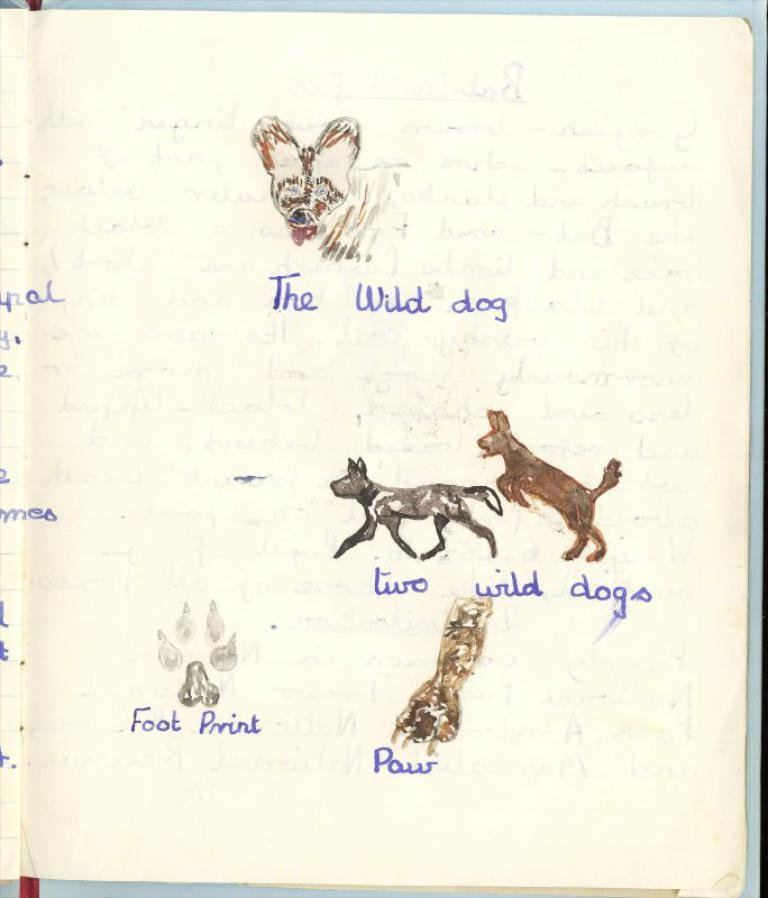What is the main object in the image? There is a book in the image. What can be found inside the book? The book contains a depiction of animals. Is there any text in the book? Yes, there is text in the book. What type of dress is the animal wearing in the image? There is no dress or animal wearing a dress in the image; the book contains a depiction of animals, but no specific clothing is mentioned. 